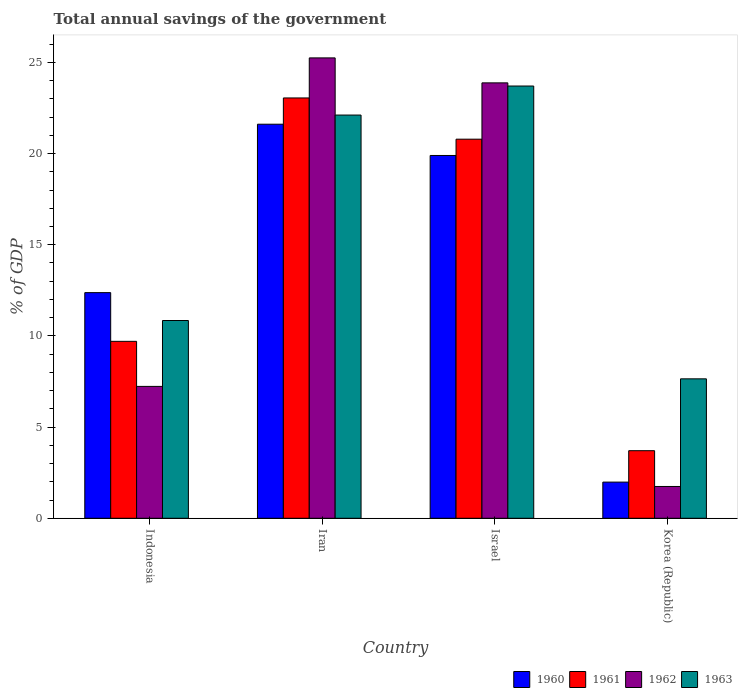How many bars are there on the 4th tick from the right?
Provide a succinct answer. 4. What is the label of the 2nd group of bars from the left?
Offer a very short reply. Iran. In how many cases, is the number of bars for a given country not equal to the number of legend labels?
Offer a very short reply. 0. What is the total annual savings of the government in 1962 in Korea (Republic)?
Offer a very short reply. 1.74. Across all countries, what is the maximum total annual savings of the government in 1960?
Provide a succinct answer. 21.61. Across all countries, what is the minimum total annual savings of the government in 1961?
Provide a short and direct response. 3.71. In which country was the total annual savings of the government in 1960 maximum?
Provide a succinct answer. Iran. In which country was the total annual savings of the government in 1963 minimum?
Give a very brief answer. Korea (Republic). What is the total total annual savings of the government in 1963 in the graph?
Keep it short and to the point. 64.31. What is the difference between the total annual savings of the government in 1963 in Indonesia and that in Israel?
Provide a succinct answer. -12.86. What is the difference between the total annual savings of the government in 1962 in Indonesia and the total annual savings of the government in 1963 in Iran?
Give a very brief answer. -14.88. What is the average total annual savings of the government in 1960 per country?
Your answer should be compact. 13.97. What is the difference between the total annual savings of the government of/in 1963 and total annual savings of the government of/in 1960 in Korea (Republic)?
Your answer should be very brief. 5.66. What is the ratio of the total annual savings of the government in 1962 in Indonesia to that in Israel?
Provide a short and direct response. 0.3. Is the total annual savings of the government in 1961 in Israel less than that in Korea (Republic)?
Make the answer very short. No. What is the difference between the highest and the second highest total annual savings of the government in 1963?
Offer a very short reply. -11.27. What is the difference between the highest and the lowest total annual savings of the government in 1961?
Your answer should be very brief. 19.34. Is the sum of the total annual savings of the government in 1962 in Indonesia and Korea (Republic) greater than the maximum total annual savings of the government in 1960 across all countries?
Provide a succinct answer. No. Is it the case that in every country, the sum of the total annual savings of the government in 1960 and total annual savings of the government in 1962 is greater than the sum of total annual savings of the government in 1961 and total annual savings of the government in 1963?
Your answer should be very brief. No. Are all the bars in the graph horizontal?
Your answer should be very brief. No. What is the difference between two consecutive major ticks on the Y-axis?
Give a very brief answer. 5. Are the values on the major ticks of Y-axis written in scientific E-notation?
Offer a very short reply. No. Does the graph contain any zero values?
Give a very brief answer. No. How many legend labels are there?
Provide a succinct answer. 4. How are the legend labels stacked?
Your answer should be very brief. Horizontal. What is the title of the graph?
Ensure brevity in your answer.  Total annual savings of the government. Does "1972" appear as one of the legend labels in the graph?
Give a very brief answer. No. What is the label or title of the X-axis?
Ensure brevity in your answer.  Country. What is the label or title of the Y-axis?
Offer a very short reply. % of GDP. What is the % of GDP of 1960 in Indonesia?
Offer a terse response. 12.37. What is the % of GDP in 1961 in Indonesia?
Ensure brevity in your answer.  9.7. What is the % of GDP in 1962 in Indonesia?
Your response must be concise. 7.23. What is the % of GDP of 1963 in Indonesia?
Offer a very short reply. 10.85. What is the % of GDP of 1960 in Iran?
Provide a succinct answer. 21.61. What is the % of GDP in 1961 in Iran?
Keep it short and to the point. 23.05. What is the % of GDP in 1962 in Iran?
Offer a very short reply. 25.25. What is the % of GDP of 1963 in Iran?
Your answer should be very brief. 22.11. What is the % of GDP of 1960 in Israel?
Make the answer very short. 19.9. What is the % of GDP in 1961 in Israel?
Keep it short and to the point. 20.79. What is the % of GDP of 1962 in Israel?
Your answer should be very brief. 23.88. What is the % of GDP in 1963 in Israel?
Your response must be concise. 23.71. What is the % of GDP of 1960 in Korea (Republic)?
Provide a succinct answer. 1.98. What is the % of GDP in 1961 in Korea (Republic)?
Ensure brevity in your answer.  3.71. What is the % of GDP in 1962 in Korea (Republic)?
Give a very brief answer. 1.74. What is the % of GDP of 1963 in Korea (Republic)?
Make the answer very short. 7.65. Across all countries, what is the maximum % of GDP of 1960?
Offer a very short reply. 21.61. Across all countries, what is the maximum % of GDP in 1961?
Offer a very short reply. 23.05. Across all countries, what is the maximum % of GDP in 1962?
Provide a short and direct response. 25.25. Across all countries, what is the maximum % of GDP of 1963?
Your response must be concise. 23.71. Across all countries, what is the minimum % of GDP in 1960?
Make the answer very short. 1.98. Across all countries, what is the minimum % of GDP of 1961?
Your response must be concise. 3.71. Across all countries, what is the minimum % of GDP of 1962?
Offer a very short reply. 1.74. Across all countries, what is the minimum % of GDP in 1963?
Give a very brief answer. 7.65. What is the total % of GDP in 1960 in the graph?
Ensure brevity in your answer.  55.86. What is the total % of GDP in 1961 in the graph?
Ensure brevity in your answer.  57.25. What is the total % of GDP in 1962 in the graph?
Your answer should be very brief. 58.1. What is the total % of GDP of 1963 in the graph?
Give a very brief answer. 64.31. What is the difference between the % of GDP in 1960 in Indonesia and that in Iran?
Your response must be concise. -9.24. What is the difference between the % of GDP of 1961 in Indonesia and that in Iran?
Make the answer very short. -13.35. What is the difference between the % of GDP in 1962 in Indonesia and that in Iran?
Provide a short and direct response. -18.02. What is the difference between the % of GDP in 1963 in Indonesia and that in Iran?
Give a very brief answer. -11.27. What is the difference between the % of GDP of 1960 in Indonesia and that in Israel?
Provide a short and direct response. -7.52. What is the difference between the % of GDP in 1961 in Indonesia and that in Israel?
Your answer should be compact. -11.09. What is the difference between the % of GDP of 1962 in Indonesia and that in Israel?
Ensure brevity in your answer.  -16.65. What is the difference between the % of GDP in 1963 in Indonesia and that in Israel?
Provide a succinct answer. -12.86. What is the difference between the % of GDP in 1960 in Indonesia and that in Korea (Republic)?
Provide a succinct answer. 10.39. What is the difference between the % of GDP in 1961 in Indonesia and that in Korea (Republic)?
Keep it short and to the point. 6. What is the difference between the % of GDP of 1962 in Indonesia and that in Korea (Republic)?
Provide a short and direct response. 5.49. What is the difference between the % of GDP of 1963 in Indonesia and that in Korea (Republic)?
Ensure brevity in your answer.  3.2. What is the difference between the % of GDP of 1960 in Iran and that in Israel?
Make the answer very short. 1.71. What is the difference between the % of GDP of 1961 in Iran and that in Israel?
Your answer should be compact. 2.26. What is the difference between the % of GDP of 1962 in Iran and that in Israel?
Your response must be concise. 1.37. What is the difference between the % of GDP of 1963 in Iran and that in Israel?
Offer a very short reply. -1.59. What is the difference between the % of GDP of 1960 in Iran and that in Korea (Republic)?
Your answer should be very brief. 19.63. What is the difference between the % of GDP in 1961 in Iran and that in Korea (Republic)?
Provide a succinct answer. 19.34. What is the difference between the % of GDP in 1962 in Iran and that in Korea (Republic)?
Give a very brief answer. 23.5. What is the difference between the % of GDP of 1963 in Iran and that in Korea (Republic)?
Provide a short and direct response. 14.47. What is the difference between the % of GDP of 1960 in Israel and that in Korea (Republic)?
Your response must be concise. 17.91. What is the difference between the % of GDP in 1961 in Israel and that in Korea (Republic)?
Make the answer very short. 17.08. What is the difference between the % of GDP of 1962 in Israel and that in Korea (Republic)?
Offer a very short reply. 22.13. What is the difference between the % of GDP of 1963 in Israel and that in Korea (Republic)?
Your answer should be very brief. 16.06. What is the difference between the % of GDP of 1960 in Indonesia and the % of GDP of 1961 in Iran?
Ensure brevity in your answer.  -10.68. What is the difference between the % of GDP in 1960 in Indonesia and the % of GDP in 1962 in Iran?
Your answer should be compact. -12.87. What is the difference between the % of GDP of 1960 in Indonesia and the % of GDP of 1963 in Iran?
Provide a succinct answer. -9.74. What is the difference between the % of GDP in 1961 in Indonesia and the % of GDP in 1962 in Iran?
Provide a short and direct response. -15.54. What is the difference between the % of GDP in 1961 in Indonesia and the % of GDP in 1963 in Iran?
Your response must be concise. -12.41. What is the difference between the % of GDP in 1962 in Indonesia and the % of GDP in 1963 in Iran?
Your answer should be compact. -14.88. What is the difference between the % of GDP in 1960 in Indonesia and the % of GDP in 1961 in Israel?
Your answer should be compact. -8.42. What is the difference between the % of GDP of 1960 in Indonesia and the % of GDP of 1962 in Israel?
Provide a short and direct response. -11.5. What is the difference between the % of GDP of 1960 in Indonesia and the % of GDP of 1963 in Israel?
Offer a terse response. -11.33. What is the difference between the % of GDP in 1961 in Indonesia and the % of GDP in 1962 in Israel?
Offer a very short reply. -14.17. What is the difference between the % of GDP of 1961 in Indonesia and the % of GDP of 1963 in Israel?
Your answer should be compact. -14. What is the difference between the % of GDP in 1962 in Indonesia and the % of GDP in 1963 in Israel?
Ensure brevity in your answer.  -16.47. What is the difference between the % of GDP in 1960 in Indonesia and the % of GDP in 1961 in Korea (Republic)?
Your answer should be compact. 8.67. What is the difference between the % of GDP in 1960 in Indonesia and the % of GDP in 1962 in Korea (Republic)?
Provide a succinct answer. 10.63. What is the difference between the % of GDP in 1960 in Indonesia and the % of GDP in 1963 in Korea (Republic)?
Keep it short and to the point. 4.73. What is the difference between the % of GDP in 1961 in Indonesia and the % of GDP in 1962 in Korea (Republic)?
Provide a short and direct response. 7.96. What is the difference between the % of GDP in 1961 in Indonesia and the % of GDP in 1963 in Korea (Republic)?
Your answer should be very brief. 2.06. What is the difference between the % of GDP in 1962 in Indonesia and the % of GDP in 1963 in Korea (Republic)?
Your answer should be very brief. -0.41. What is the difference between the % of GDP in 1960 in Iran and the % of GDP in 1961 in Israel?
Offer a very short reply. 0.82. What is the difference between the % of GDP in 1960 in Iran and the % of GDP in 1962 in Israel?
Make the answer very short. -2.27. What is the difference between the % of GDP of 1960 in Iran and the % of GDP of 1963 in Israel?
Your answer should be compact. -2.09. What is the difference between the % of GDP of 1961 in Iran and the % of GDP of 1962 in Israel?
Your answer should be very brief. -0.83. What is the difference between the % of GDP in 1961 in Iran and the % of GDP in 1963 in Israel?
Your answer should be compact. -0.65. What is the difference between the % of GDP of 1962 in Iran and the % of GDP of 1963 in Israel?
Your answer should be compact. 1.54. What is the difference between the % of GDP in 1960 in Iran and the % of GDP in 1961 in Korea (Republic)?
Give a very brief answer. 17.9. What is the difference between the % of GDP in 1960 in Iran and the % of GDP in 1962 in Korea (Republic)?
Your answer should be very brief. 19.87. What is the difference between the % of GDP of 1960 in Iran and the % of GDP of 1963 in Korea (Republic)?
Your answer should be compact. 13.96. What is the difference between the % of GDP of 1961 in Iran and the % of GDP of 1962 in Korea (Republic)?
Ensure brevity in your answer.  21.31. What is the difference between the % of GDP of 1961 in Iran and the % of GDP of 1963 in Korea (Republic)?
Your answer should be very brief. 15.4. What is the difference between the % of GDP of 1962 in Iran and the % of GDP of 1963 in Korea (Republic)?
Offer a very short reply. 17.6. What is the difference between the % of GDP in 1960 in Israel and the % of GDP in 1961 in Korea (Republic)?
Ensure brevity in your answer.  16.19. What is the difference between the % of GDP in 1960 in Israel and the % of GDP in 1962 in Korea (Republic)?
Offer a very short reply. 18.15. What is the difference between the % of GDP in 1960 in Israel and the % of GDP in 1963 in Korea (Republic)?
Provide a short and direct response. 12.25. What is the difference between the % of GDP in 1961 in Israel and the % of GDP in 1962 in Korea (Republic)?
Offer a terse response. 19.05. What is the difference between the % of GDP in 1961 in Israel and the % of GDP in 1963 in Korea (Republic)?
Offer a very short reply. 13.14. What is the difference between the % of GDP of 1962 in Israel and the % of GDP of 1963 in Korea (Republic)?
Provide a succinct answer. 16.23. What is the average % of GDP of 1960 per country?
Give a very brief answer. 13.97. What is the average % of GDP in 1961 per country?
Offer a terse response. 14.31. What is the average % of GDP in 1962 per country?
Your answer should be very brief. 14.53. What is the average % of GDP in 1963 per country?
Provide a short and direct response. 16.08. What is the difference between the % of GDP of 1960 and % of GDP of 1961 in Indonesia?
Your answer should be very brief. 2.67. What is the difference between the % of GDP in 1960 and % of GDP in 1962 in Indonesia?
Ensure brevity in your answer.  5.14. What is the difference between the % of GDP of 1960 and % of GDP of 1963 in Indonesia?
Give a very brief answer. 1.53. What is the difference between the % of GDP of 1961 and % of GDP of 1962 in Indonesia?
Give a very brief answer. 2.47. What is the difference between the % of GDP of 1961 and % of GDP of 1963 in Indonesia?
Keep it short and to the point. -1.14. What is the difference between the % of GDP of 1962 and % of GDP of 1963 in Indonesia?
Provide a short and direct response. -3.61. What is the difference between the % of GDP of 1960 and % of GDP of 1961 in Iran?
Ensure brevity in your answer.  -1.44. What is the difference between the % of GDP in 1960 and % of GDP in 1962 in Iran?
Provide a short and direct response. -3.64. What is the difference between the % of GDP of 1960 and % of GDP of 1963 in Iran?
Your answer should be very brief. -0.5. What is the difference between the % of GDP of 1961 and % of GDP of 1962 in Iran?
Make the answer very short. -2.2. What is the difference between the % of GDP of 1961 and % of GDP of 1963 in Iran?
Make the answer very short. 0.94. What is the difference between the % of GDP in 1962 and % of GDP in 1963 in Iran?
Provide a short and direct response. 3.13. What is the difference between the % of GDP of 1960 and % of GDP of 1961 in Israel?
Your answer should be very brief. -0.89. What is the difference between the % of GDP in 1960 and % of GDP in 1962 in Israel?
Keep it short and to the point. -3.98. What is the difference between the % of GDP of 1960 and % of GDP of 1963 in Israel?
Offer a terse response. -3.81. What is the difference between the % of GDP of 1961 and % of GDP of 1962 in Israel?
Offer a very short reply. -3.09. What is the difference between the % of GDP of 1961 and % of GDP of 1963 in Israel?
Offer a very short reply. -2.91. What is the difference between the % of GDP of 1962 and % of GDP of 1963 in Israel?
Provide a succinct answer. 0.17. What is the difference between the % of GDP of 1960 and % of GDP of 1961 in Korea (Republic)?
Offer a very short reply. -1.72. What is the difference between the % of GDP of 1960 and % of GDP of 1962 in Korea (Republic)?
Keep it short and to the point. 0.24. What is the difference between the % of GDP of 1960 and % of GDP of 1963 in Korea (Republic)?
Give a very brief answer. -5.66. What is the difference between the % of GDP of 1961 and % of GDP of 1962 in Korea (Republic)?
Your response must be concise. 1.96. What is the difference between the % of GDP in 1961 and % of GDP in 1963 in Korea (Republic)?
Your answer should be compact. -3.94. What is the difference between the % of GDP of 1962 and % of GDP of 1963 in Korea (Republic)?
Offer a terse response. -5.9. What is the ratio of the % of GDP of 1960 in Indonesia to that in Iran?
Provide a succinct answer. 0.57. What is the ratio of the % of GDP in 1961 in Indonesia to that in Iran?
Offer a very short reply. 0.42. What is the ratio of the % of GDP in 1962 in Indonesia to that in Iran?
Your answer should be very brief. 0.29. What is the ratio of the % of GDP in 1963 in Indonesia to that in Iran?
Your answer should be very brief. 0.49. What is the ratio of the % of GDP of 1960 in Indonesia to that in Israel?
Keep it short and to the point. 0.62. What is the ratio of the % of GDP in 1961 in Indonesia to that in Israel?
Ensure brevity in your answer.  0.47. What is the ratio of the % of GDP in 1962 in Indonesia to that in Israel?
Provide a short and direct response. 0.3. What is the ratio of the % of GDP of 1963 in Indonesia to that in Israel?
Make the answer very short. 0.46. What is the ratio of the % of GDP in 1960 in Indonesia to that in Korea (Republic)?
Your answer should be compact. 6.24. What is the ratio of the % of GDP of 1961 in Indonesia to that in Korea (Republic)?
Provide a short and direct response. 2.62. What is the ratio of the % of GDP in 1962 in Indonesia to that in Korea (Republic)?
Make the answer very short. 4.15. What is the ratio of the % of GDP of 1963 in Indonesia to that in Korea (Republic)?
Keep it short and to the point. 1.42. What is the ratio of the % of GDP in 1960 in Iran to that in Israel?
Your response must be concise. 1.09. What is the ratio of the % of GDP of 1961 in Iran to that in Israel?
Make the answer very short. 1.11. What is the ratio of the % of GDP in 1962 in Iran to that in Israel?
Keep it short and to the point. 1.06. What is the ratio of the % of GDP in 1963 in Iran to that in Israel?
Offer a terse response. 0.93. What is the ratio of the % of GDP of 1960 in Iran to that in Korea (Republic)?
Your answer should be very brief. 10.89. What is the ratio of the % of GDP of 1961 in Iran to that in Korea (Republic)?
Keep it short and to the point. 6.22. What is the ratio of the % of GDP of 1962 in Iran to that in Korea (Republic)?
Your answer should be compact. 14.48. What is the ratio of the % of GDP in 1963 in Iran to that in Korea (Republic)?
Give a very brief answer. 2.89. What is the ratio of the % of GDP in 1960 in Israel to that in Korea (Republic)?
Your response must be concise. 10.03. What is the ratio of the % of GDP in 1961 in Israel to that in Korea (Republic)?
Your answer should be compact. 5.61. What is the ratio of the % of GDP in 1962 in Israel to that in Korea (Republic)?
Keep it short and to the point. 13.69. What is the ratio of the % of GDP in 1963 in Israel to that in Korea (Republic)?
Offer a terse response. 3.1. What is the difference between the highest and the second highest % of GDP in 1960?
Offer a very short reply. 1.71. What is the difference between the highest and the second highest % of GDP in 1961?
Provide a short and direct response. 2.26. What is the difference between the highest and the second highest % of GDP in 1962?
Provide a succinct answer. 1.37. What is the difference between the highest and the second highest % of GDP of 1963?
Provide a succinct answer. 1.59. What is the difference between the highest and the lowest % of GDP of 1960?
Offer a very short reply. 19.63. What is the difference between the highest and the lowest % of GDP in 1961?
Provide a succinct answer. 19.34. What is the difference between the highest and the lowest % of GDP in 1962?
Provide a short and direct response. 23.5. What is the difference between the highest and the lowest % of GDP in 1963?
Give a very brief answer. 16.06. 